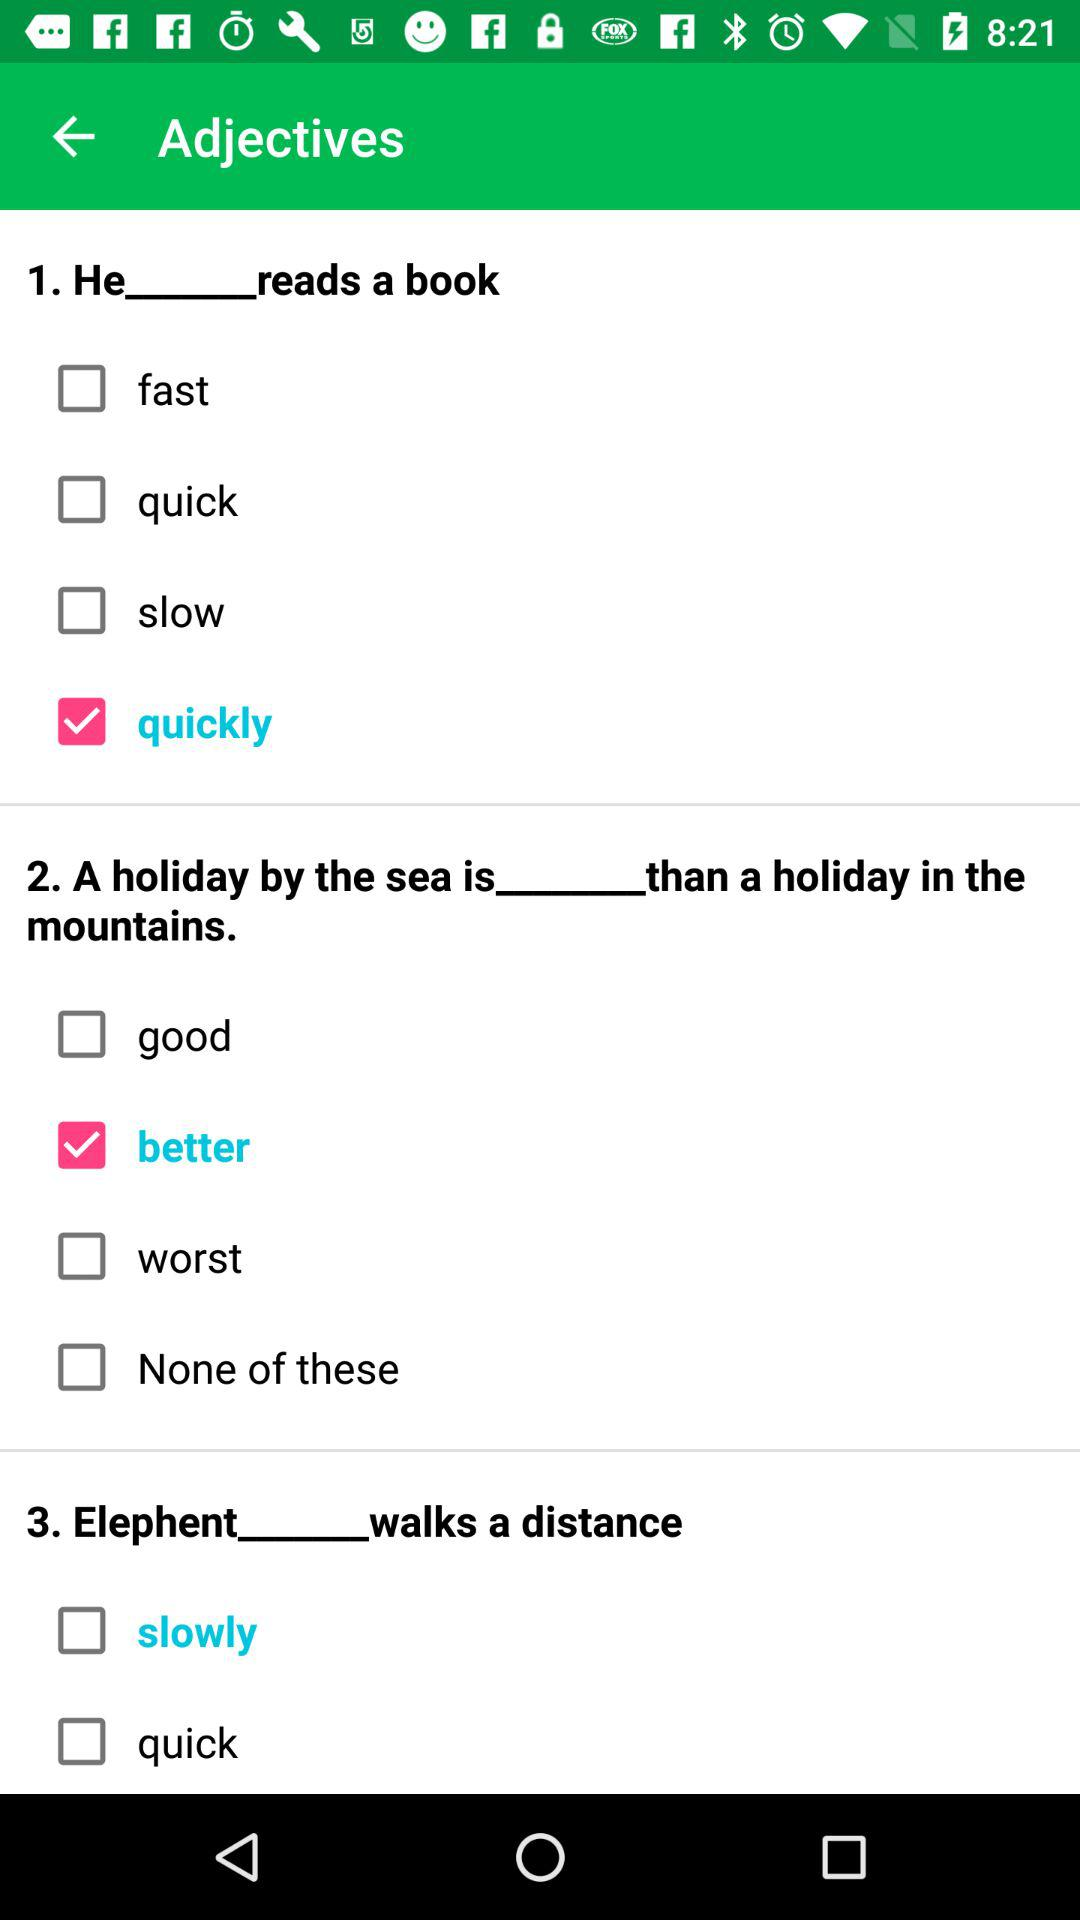Which is the selected option for question 1? The selected option is quickly. 